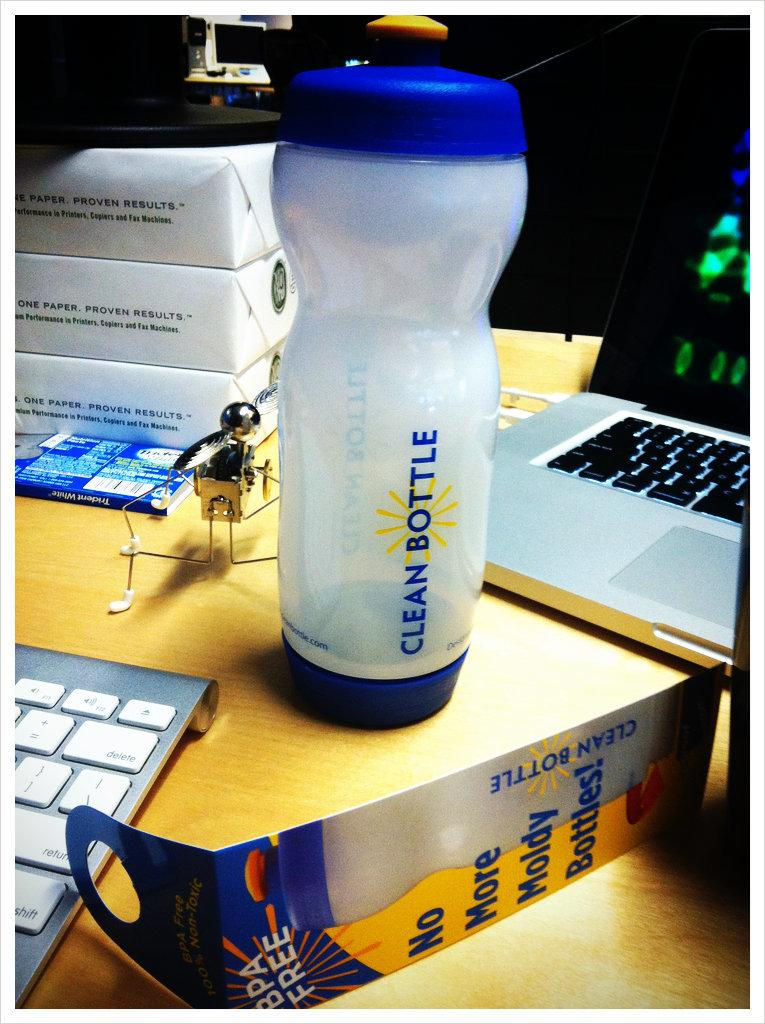What object in the image is typically used for holding liquids? There is a bottle in the image, which is typically used for holding liquids. What electronic device can be seen in the image? There is a laptop in the image. What input device is present in the image? There is a keyboard in the image. What type of rock can be seen in the image? There is no rock present in the image. Is there any snow visible in the image? There is no snow present in the image. What type of event is taking place in the image? There is no event taking place in the image; it simply shows a bottle, a laptop, and a keyboard. 